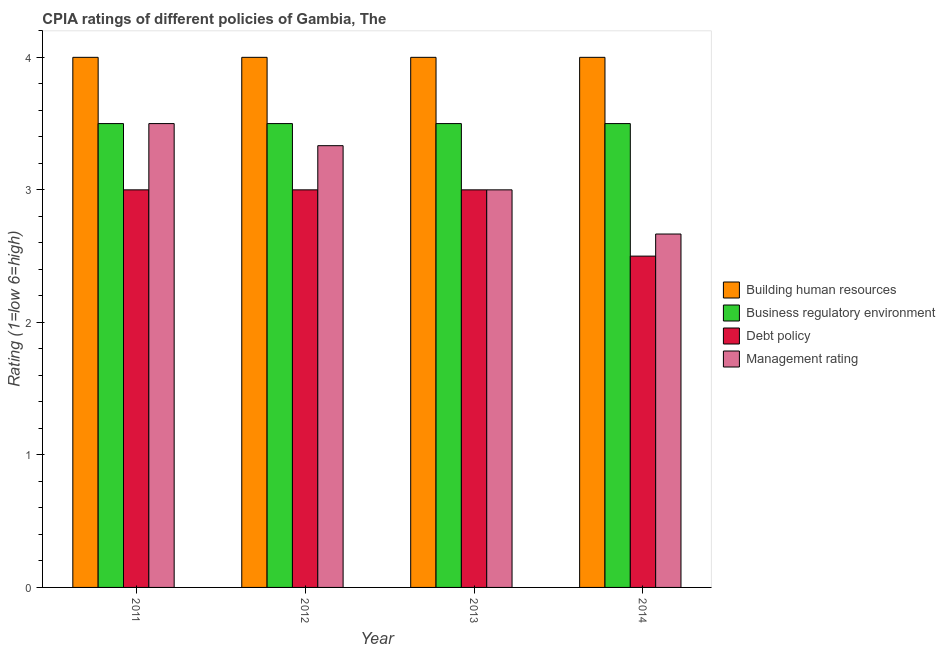How many groups of bars are there?
Keep it short and to the point. 4. Are the number of bars per tick equal to the number of legend labels?
Make the answer very short. Yes. How many bars are there on the 3rd tick from the left?
Provide a short and direct response. 4. How many bars are there on the 1st tick from the right?
Give a very brief answer. 4. Across all years, what is the minimum cpia rating of management?
Your response must be concise. 2.67. What is the difference between the cpia rating of debt policy in 2011 and that in 2013?
Your answer should be very brief. 0. What is the difference between the cpia rating of management in 2012 and the cpia rating of debt policy in 2013?
Offer a very short reply. 0.33. What is the average cpia rating of business regulatory environment per year?
Provide a succinct answer. 3.5. In the year 2014, what is the difference between the cpia rating of debt policy and cpia rating of business regulatory environment?
Your answer should be compact. 0. In how many years, is the cpia rating of management greater than 1?
Your response must be concise. 4. What is the ratio of the cpia rating of management in 2012 to that in 2013?
Ensure brevity in your answer.  1.11. Is the difference between the cpia rating of building human resources in 2011 and 2014 greater than the difference between the cpia rating of business regulatory environment in 2011 and 2014?
Offer a terse response. No. What is the difference between the highest and the second highest cpia rating of management?
Offer a very short reply. 0.17. What is the difference between the highest and the lowest cpia rating of debt policy?
Give a very brief answer. 0.5. In how many years, is the cpia rating of management greater than the average cpia rating of management taken over all years?
Your response must be concise. 2. Is it the case that in every year, the sum of the cpia rating of debt policy and cpia rating of management is greater than the sum of cpia rating of building human resources and cpia rating of business regulatory environment?
Provide a short and direct response. No. What does the 3rd bar from the left in 2013 represents?
Make the answer very short. Debt policy. What does the 3rd bar from the right in 2014 represents?
Provide a succinct answer. Business regulatory environment. Is it the case that in every year, the sum of the cpia rating of building human resources and cpia rating of business regulatory environment is greater than the cpia rating of debt policy?
Offer a very short reply. Yes. How many bars are there?
Provide a short and direct response. 16. Are all the bars in the graph horizontal?
Ensure brevity in your answer.  No. What is the difference between two consecutive major ticks on the Y-axis?
Your answer should be very brief. 1. Does the graph contain grids?
Provide a short and direct response. No. Where does the legend appear in the graph?
Ensure brevity in your answer.  Center right. How many legend labels are there?
Provide a succinct answer. 4. How are the legend labels stacked?
Make the answer very short. Vertical. What is the title of the graph?
Give a very brief answer. CPIA ratings of different policies of Gambia, The. What is the label or title of the X-axis?
Provide a short and direct response. Year. What is the Rating (1=low 6=high) of Building human resources in 2011?
Your answer should be compact. 4. What is the Rating (1=low 6=high) of Business regulatory environment in 2011?
Your response must be concise. 3.5. What is the Rating (1=low 6=high) in Debt policy in 2011?
Make the answer very short. 3. What is the Rating (1=low 6=high) in Building human resources in 2012?
Provide a succinct answer. 4. What is the Rating (1=low 6=high) in Debt policy in 2012?
Ensure brevity in your answer.  3. What is the Rating (1=low 6=high) of Management rating in 2012?
Provide a short and direct response. 3.33. What is the Rating (1=low 6=high) of Business regulatory environment in 2013?
Provide a short and direct response. 3.5. What is the Rating (1=low 6=high) of Management rating in 2013?
Give a very brief answer. 3. What is the Rating (1=low 6=high) in Business regulatory environment in 2014?
Give a very brief answer. 3.5. What is the Rating (1=low 6=high) in Management rating in 2014?
Your response must be concise. 2.67. Across all years, what is the maximum Rating (1=low 6=high) in Management rating?
Give a very brief answer. 3.5. Across all years, what is the minimum Rating (1=low 6=high) of Management rating?
Provide a short and direct response. 2.67. What is the total Rating (1=low 6=high) in Building human resources in the graph?
Your answer should be compact. 16. What is the total Rating (1=low 6=high) in Debt policy in the graph?
Make the answer very short. 11.5. What is the difference between the Rating (1=low 6=high) in Building human resources in 2011 and that in 2012?
Keep it short and to the point. 0. What is the difference between the Rating (1=low 6=high) in Debt policy in 2011 and that in 2012?
Provide a succinct answer. 0. What is the difference between the Rating (1=low 6=high) of Business regulatory environment in 2011 and that in 2014?
Offer a terse response. 0. What is the difference between the Rating (1=low 6=high) of Debt policy in 2011 and that in 2014?
Offer a terse response. 0.5. What is the difference between the Rating (1=low 6=high) in Management rating in 2011 and that in 2014?
Provide a succinct answer. 0.83. What is the difference between the Rating (1=low 6=high) of Building human resources in 2012 and that in 2013?
Keep it short and to the point. 0. What is the difference between the Rating (1=low 6=high) in Debt policy in 2012 and that in 2013?
Ensure brevity in your answer.  0. What is the difference between the Rating (1=low 6=high) of Business regulatory environment in 2013 and that in 2014?
Your answer should be very brief. 0. What is the difference between the Rating (1=low 6=high) of Debt policy in 2013 and that in 2014?
Your answer should be compact. 0.5. What is the difference between the Rating (1=low 6=high) of Building human resources in 2011 and the Rating (1=low 6=high) of Business regulatory environment in 2012?
Give a very brief answer. 0.5. What is the difference between the Rating (1=low 6=high) of Business regulatory environment in 2011 and the Rating (1=low 6=high) of Management rating in 2012?
Make the answer very short. 0.17. What is the difference between the Rating (1=low 6=high) in Building human resources in 2011 and the Rating (1=low 6=high) in Debt policy in 2013?
Offer a very short reply. 1. What is the difference between the Rating (1=low 6=high) in Building human resources in 2011 and the Rating (1=low 6=high) in Debt policy in 2014?
Your answer should be very brief. 1.5. What is the difference between the Rating (1=low 6=high) of Business regulatory environment in 2011 and the Rating (1=low 6=high) of Debt policy in 2014?
Make the answer very short. 1. What is the difference between the Rating (1=low 6=high) of Business regulatory environment in 2011 and the Rating (1=low 6=high) of Management rating in 2014?
Provide a succinct answer. 0.83. What is the difference between the Rating (1=low 6=high) of Debt policy in 2011 and the Rating (1=low 6=high) of Management rating in 2014?
Ensure brevity in your answer.  0.33. What is the difference between the Rating (1=low 6=high) in Building human resources in 2012 and the Rating (1=low 6=high) in Debt policy in 2013?
Ensure brevity in your answer.  1. What is the difference between the Rating (1=low 6=high) in Business regulatory environment in 2012 and the Rating (1=low 6=high) in Debt policy in 2013?
Offer a terse response. 0.5. What is the difference between the Rating (1=low 6=high) of Business regulatory environment in 2012 and the Rating (1=low 6=high) of Management rating in 2013?
Give a very brief answer. 0.5. What is the difference between the Rating (1=low 6=high) in Building human resources in 2012 and the Rating (1=low 6=high) in Business regulatory environment in 2014?
Your answer should be very brief. 0.5. What is the difference between the Rating (1=low 6=high) in Building human resources in 2012 and the Rating (1=low 6=high) in Debt policy in 2014?
Your answer should be very brief. 1.5. What is the difference between the Rating (1=low 6=high) in Building human resources in 2012 and the Rating (1=low 6=high) in Management rating in 2014?
Provide a succinct answer. 1.33. What is the difference between the Rating (1=low 6=high) in Business regulatory environment in 2012 and the Rating (1=low 6=high) in Management rating in 2014?
Offer a terse response. 0.83. What is the difference between the Rating (1=low 6=high) in Debt policy in 2012 and the Rating (1=low 6=high) in Management rating in 2014?
Ensure brevity in your answer.  0.33. What is the difference between the Rating (1=low 6=high) in Building human resources in 2013 and the Rating (1=low 6=high) in Debt policy in 2014?
Your answer should be very brief. 1.5. What is the difference between the Rating (1=low 6=high) in Building human resources in 2013 and the Rating (1=low 6=high) in Management rating in 2014?
Ensure brevity in your answer.  1.33. What is the difference between the Rating (1=low 6=high) of Business regulatory environment in 2013 and the Rating (1=low 6=high) of Management rating in 2014?
Provide a short and direct response. 0.83. What is the average Rating (1=low 6=high) in Business regulatory environment per year?
Offer a very short reply. 3.5. What is the average Rating (1=low 6=high) in Debt policy per year?
Make the answer very short. 2.88. What is the average Rating (1=low 6=high) of Management rating per year?
Your answer should be compact. 3.12. In the year 2011, what is the difference between the Rating (1=low 6=high) in Building human resources and Rating (1=low 6=high) in Business regulatory environment?
Keep it short and to the point. 0.5. In the year 2011, what is the difference between the Rating (1=low 6=high) of Building human resources and Rating (1=low 6=high) of Management rating?
Offer a very short reply. 0.5. In the year 2011, what is the difference between the Rating (1=low 6=high) of Business regulatory environment and Rating (1=low 6=high) of Debt policy?
Give a very brief answer. 0.5. In the year 2011, what is the difference between the Rating (1=low 6=high) in Business regulatory environment and Rating (1=low 6=high) in Management rating?
Give a very brief answer. 0. In the year 2012, what is the difference between the Rating (1=low 6=high) in Building human resources and Rating (1=low 6=high) in Debt policy?
Ensure brevity in your answer.  1. In the year 2013, what is the difference between the Rating (1=low 6=high) in Building human resources and Rating (1=low 6=high) in Debt policy?
Provide a succinct answer. 1. In the year 2013, what is the difference between the Rating (1=low 6=high) of Building human resources and Rating (1=low 6=high) of Management rating?
Keep it short and to the point. 1. In the year 2013, what is the difference between the Rating (1=low 6=high) in Business regulatory environment and Rating (1=low 6=high) in Debt policy?
Ensure brevity in your answer.  0.5. In the year 2014, what is the difference between the Rating (1=low 6=high) in Debt policy and Rating (1=low 6=high) in Management rating?
Keep it short and to the point. -0.17. What is the ratio of the Rating (1=low 6=high) in Business regulatory environment in 2011 to that in 2012?
Your response must be concise. 1. What is the ratio of the Rating (1=low 6=high) of Management rating in 2011 to that in 2012?
Offer a terse response. 1.05. What is the ratio of the Rating (1=low 6=high) of Building human resources in 2011 to that in 2013?
Ensure brevity in your answer.  1. What is the ratio of the Rating (1=low 6=high) of Business regulatory environment in 2011 to that in 2014?
Give a very brief answer. 1. What is the ratio of the Rating (1=low 6=high) of Debt policy in 2011 to that in 2014?
Make the answer very short. 1.2. What is the ratio of the Rating (1=low 6=high) in Management rating in 2011 to that in 2014?
Keep it short and to the point. 1.31. What is the ratio of the Rating (1=low 6=high) of Business regulatory environment in 2012 to that in 2013?
Ensure brevity in your answer.  1. What is the ratio of the Rating (1=low 6=high) of Debt policy in 2012 to that in 2013?
Your answer should be very brief. 1. What is the ratio of the Rating (1=low 6=high) of Business regulatory environment in 2012 to that in 2014?
Provide a short and direct response. 1. What is the ratio of the Rating (1=low 6=high) in Debt policy in 2012 to that in 2014?
Your answer should be very brief. 1.2. What is the ratio of the Rating (1=low 6=high) in Management rating in 2012 to that in 2014?
Ensure brevity in your answer.  1.25. What is the ratio of the Rating (1=low 6=high) in Business regulatory environment in 2013 to that in 2014?
Ensure brevity in your answer.  1. What is the ratio of the Rating (1=low 6=high) of Debt policy in 2013 to that in 2014?
Make the answer very short. 1.2. What is the ratio of the Rating (1=low 6=high) in Management rating in 2013 to that in 2014?
Offer a very short reply. 1.12. What is the difference between the highest and the second highest Rating (1=low 6=high) of Building human resources?
Ensure brevity in your answer.  0. What is the difference between the highest and the second highest Rating (1=low 6=high) in Management rating?
Offer a very short reply. 0.17. What is the difference between the highest and the lowest Rating (1=low 6=high) of Management rating?
Provide a succinct answer. 0.83. 